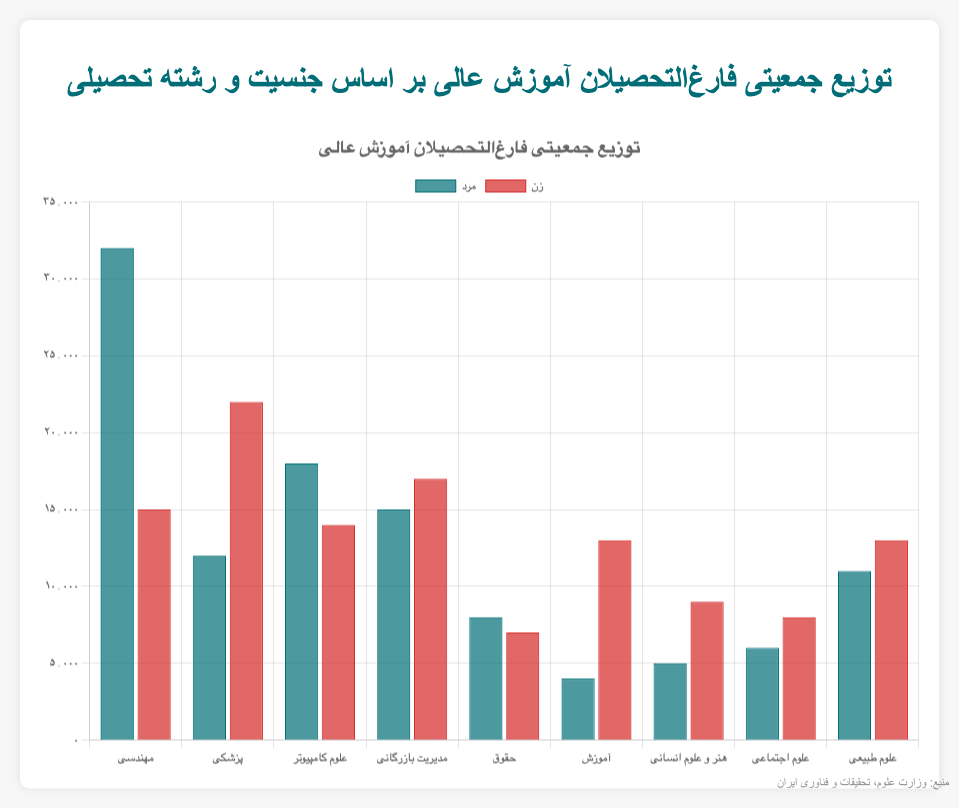Which field of study has the highest number of male graduates? First, observe the heights of the bars representing "male" graduates in the chart. The tallest bar corresponds to "Engineering".
Answer: Engineering In which field do female graduates outnumber male graduates by the largest margin? Look at the difference in heights between male and female bars for each field. The largest difference is in "Medicine", where female graduates (22000) significantly outnumber male graduates (12000) by 10000.
Answer: Medicine What is the total number of graduates (both male and female) in the field of Computer Science? Sum the number of male graduates (18000) and female graduates (14000) in Computer Science: 18000 + 14000 = 32000.
Answer: 32000 Which field has approximately an equal number of male and female graduates? Compare the heights of the bars for both genders. "Law" has the most similar numbers with 8000 male and 7000 female graduates.
Answer: Law Between "Engineering" and "Natural Sciences", which field has more total graduates? Sum up the number of male and female graduates in each field. "Engineering" has 32000 (male) + 15000 (female) = 47000, while "Natural Sciences" has 11000 (male) + 13000 (female) = 24000. So, "Engineering" has more graduates.
Answer: Engineering How many more male graduates are there in "Engineering" compared to "Business Administration"? Subtract the number of male graduates in Business Administration (15000) from those in Engineering (32000): 32000 - 15000 = 17000.
Answer: 17000 Which field has the lowest number of male graduates? Identify the shortest bar among the "male" bars. The shortest bar corresponds to "Education" with 4000 male graduates.
Answer: Education In the field of "Art and Humanities", what is the ratio of female to male graduates? The number of female graduates is 9000, and the number of male graduates is 5000. The ratio of female to male graduates is 9000:5000, which simplifies to 9:5.
Answer: 9:5 Which field shows the greatest gender disparity in favor of male graduates? Identify the field with the largest positive difference between male and female graduate numbers. For "Engineering", the difference is 32000 (male) - 15000 (female) = 17000. This is the largest positive difference.
Answer: Engineering What is the total number of female graduates across all fields of study? Sum the number of female graduates in each field: 15000 + 22000 + 14000 + 17000 + 7000 + 13000 + 9000 + 8000 + 13000. This sums up to 118000.
Answer: 118000 